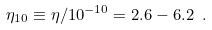<formula> <loc_0><loc_0><loc_500><loc_500>\eta _ { 1 0 } \equiv \eta / 1 0 ^ { - 1 0 } = 2 . 6 - 6 . 2 \ .</formula> 